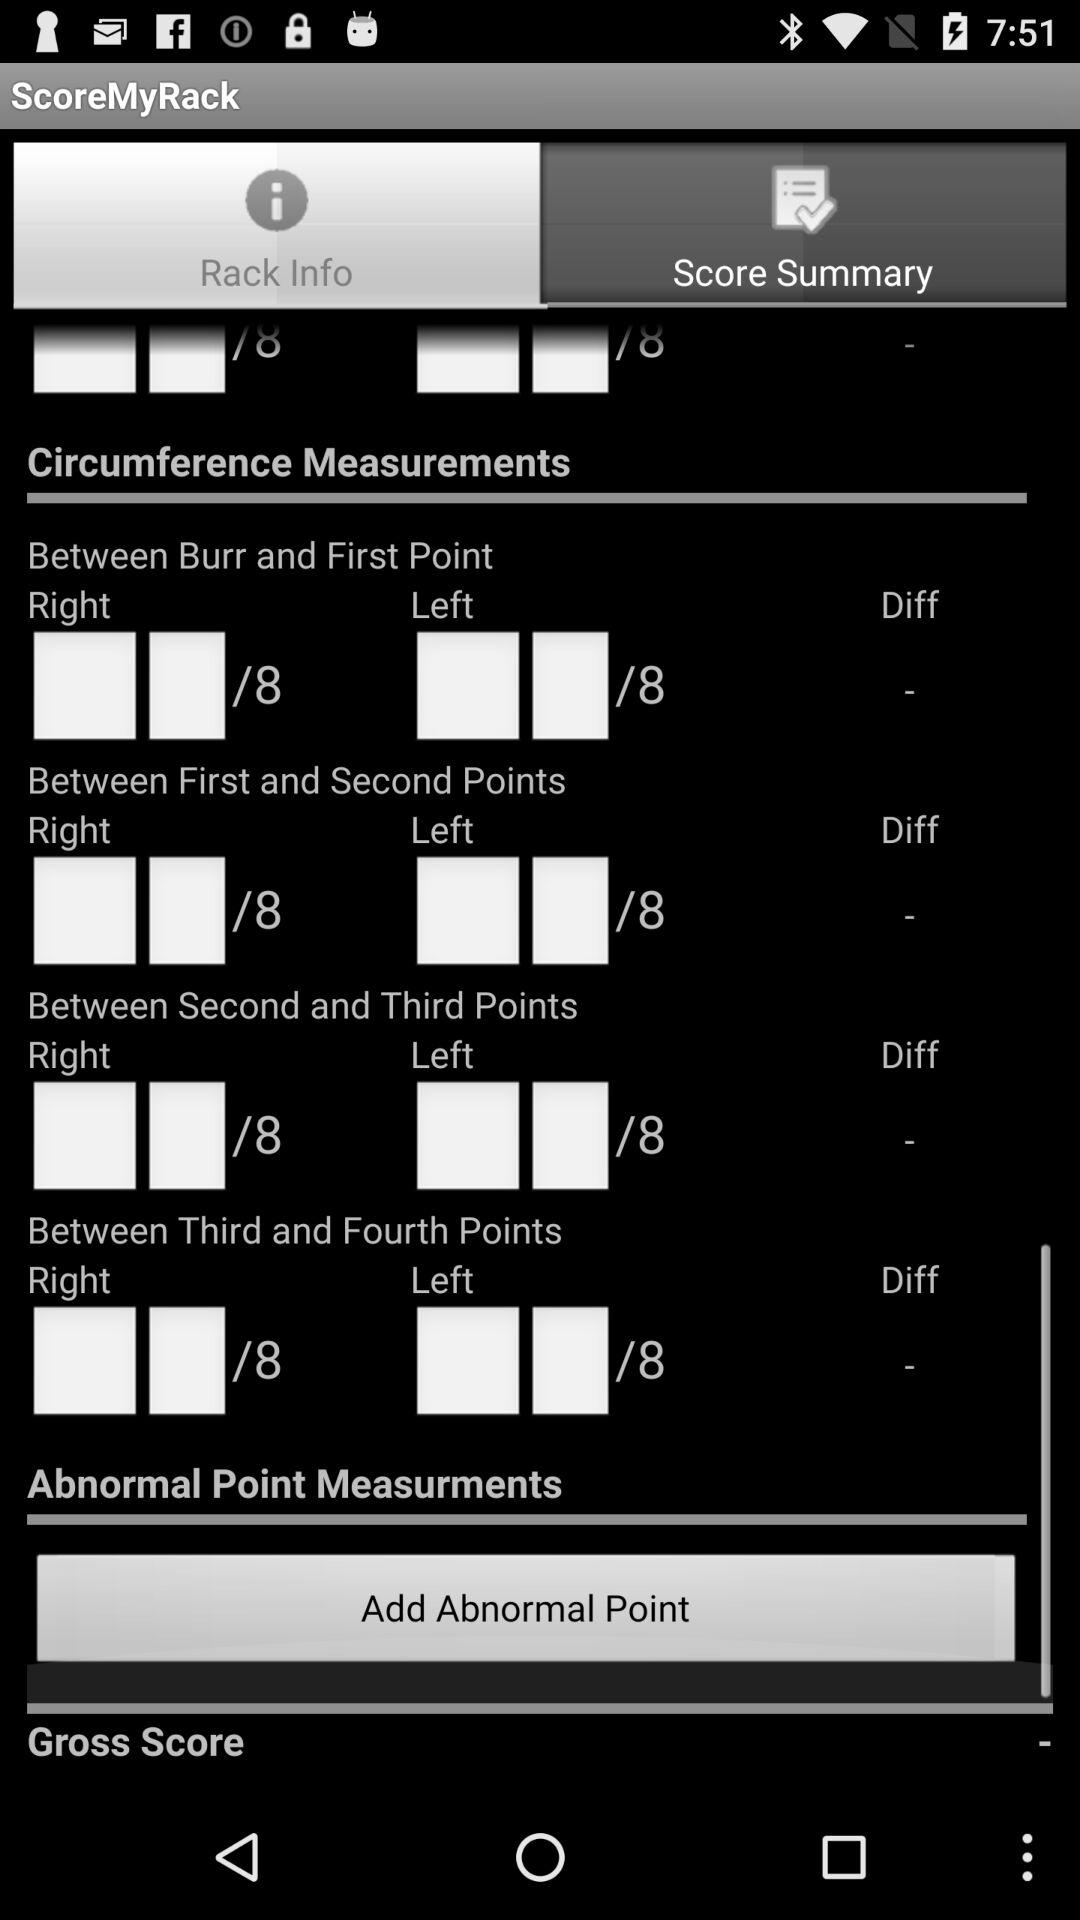What is the score summary?
When the provided information is insufficient, respond with <no answer>. <no answer> 